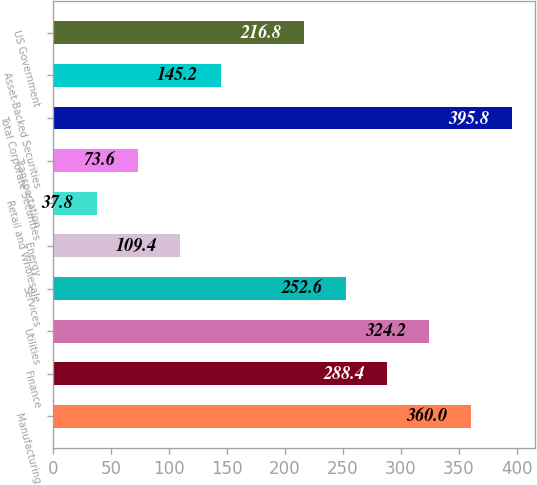Convert chart. <chart><loc_0><loc_0><loc_500><loc_500><bar_chart><fcel>Manufacturing<fcel>Finance<fcel>Utilities<fcel>Services<fcel>Energy<fcel>Retail and Wholesale<fcel>Transportation<fcel>Total Corporate Securities<fcel>Asset-Backed Securities<fcel>US Government<nl><fcel>360<fcel>288.4<fcel>324.2<fcel>252.6<fcel>109.4<fcel>37.8<fcel>73.6<fcel>395.8<fcel>145.2<fcel>216.8<nl></chart> 